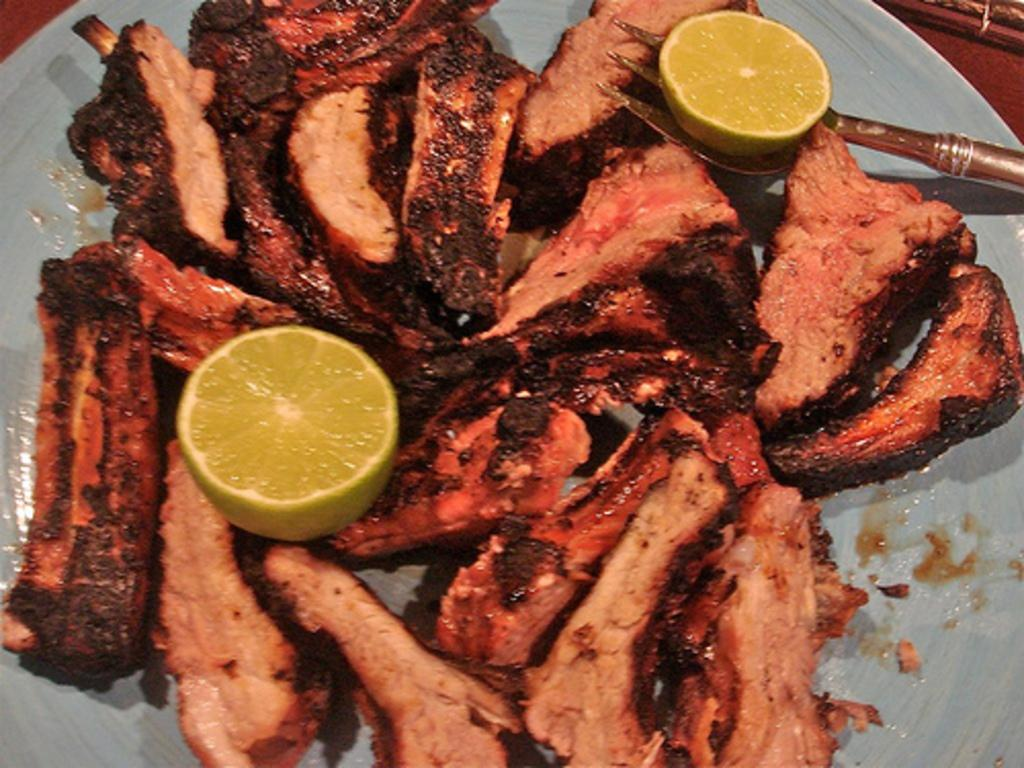What is on the plate that is visible in the image? The plate contains food items. Can you identify any specific food items on the plate? Yes, lemon pieces are present on the plate. What utensil is associated with the plate in the image? There is a fork on or near the plate. What type of net can be seen in the image? There is no net present in the image. Is there a shirt visible on the plate? No, there is no shirt present on the plate. 